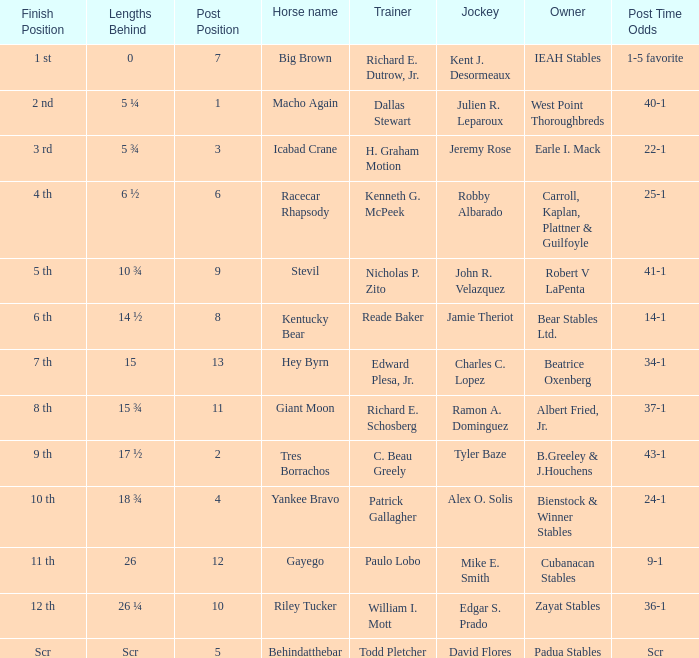Who was the jockey that had post time odds of 34-1? Charles C. Lopez. 